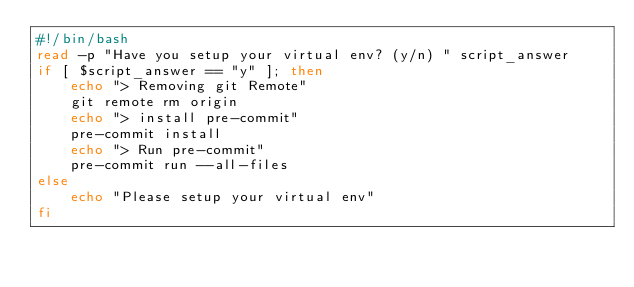<code> <loc_0><loc_0><loc_500><loc_500><_Bash_>#!/bin/bash
read -p "Have you setup your virtual env? (y/n) " script_answer
if [ $script_answer == "y" ]; then
    echo "> Removing git Remote"
    git remote rm origin
    echo "> install pre-commit"
    pre-commit install
    echo "> Run pre-commit"
    pre-commit run --all-files
else
    echo "Please setup your virtual env"
fi
</code> 